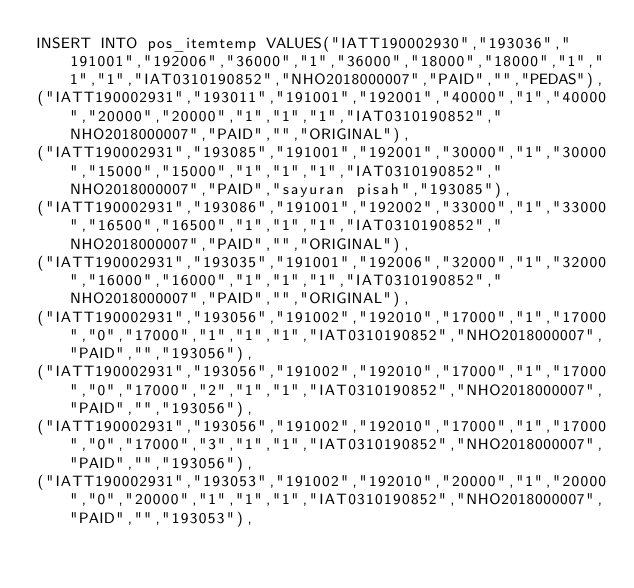Convert code to text. <code><loc_0><loc_0><loc_500><loc_500><_SQL_>INSERT INTO pos_itemtemp VALUES("IATT190002930","193036","191001","192006","36000","1","36000","18000","18000","1","1","1","IAT0310190852","NHO2018000007","PAID","","PEDAS"),
("IATT190002931","193011","191001","192001","40000","1","40000","20000","20000","1","1","1","IAT0310190852","NHO2018000007","PAID","","ORIGINAL"),
("IATT190002931","193085","191001","192001","30000","1","30000","15000","15000","1","1","1","IAT0310190852","NHO2018000007","PAID","sayuran pisah","193085"),
("IATT190002931","193086","191001","192002","33000","1","33000","16500","16500","1","1","1","IAT0310190852","NHO2018000007","PAID","","ORIGINAL"),
("IATT190002931","193035","191001","192006","32000","1","32000","16000","16000","1","1","1","IAT0310190852","NHO2018000007","PAID","","ORIGINAL"),
("IATT190002931","193056","191002","192010","17000","1","17000","0","17000","1","1","1","IAT0310190852","NHO2018000007","PAID","","193056"),
("IATT190002931","193056","191002","192010","17000","1","17000","0","17000","2","1","1","IAT0310190852","NHO2018000007","PAID","","193056"),
("IATT190002931","193056","191002","192010","17000","1","17000","0","17000","3","1","1","IAT0310190852","NHO2018000007","PAID","","193056"),
("IATT190002931","193053","191002","192010","20000","1","20000","0","20000","1","1","1","IAT0310190852","NHO2018000007","PAID","","193053"),</code> 